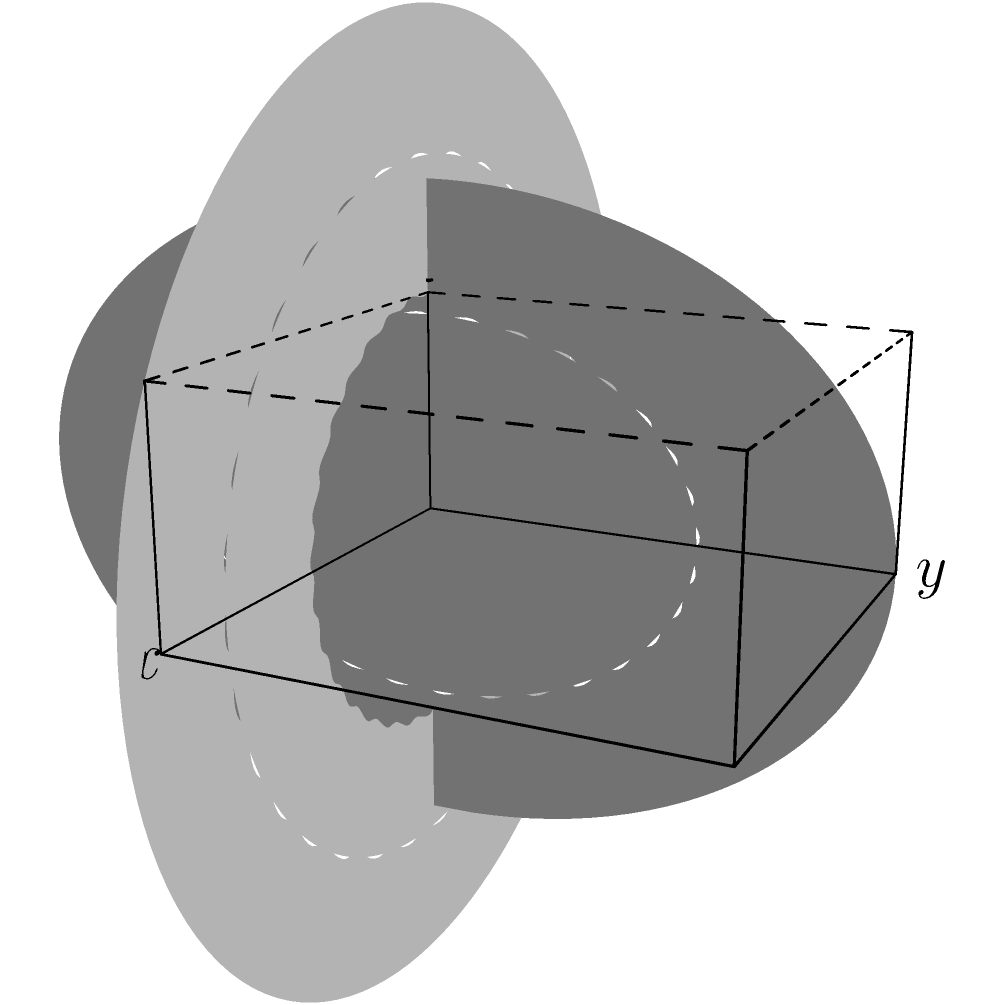As a jazz pianist, you're intrigued by the mathematical modeling of your instrument. Consider a grand piano modeled as a 3D shape with curved surfaces, as shown in the figure. The top surface is defined by the function $z = f(x) = 2 + 0.5\sin(\frac{\pi x}{4})$ for $0 \leq x \leq 4$, and the side surface is defined by $z = g(y) = 2\sin(\frac{\pi y}{3})$ for $0 \leq y \leq 3$. Calculate the volume of this piano model using triple integration. To calculate the volume of the piano model, we need to set up a triple integral. We'll integrate over x, y, and z in that order.

Step 1: Determine the limits of integration
x: 0 to 4
y: 0 to 3
z: 0 to min(f(x), g(y))

Step 2: Set up the triple integral
$$V = \int_0^4 \int_0^3 \int_0^{\min(f(x),g(y))} dz dy dx$$

Step 3: Evaluate the innermost integral
$$V = \int_0^4 \int_0^3 \min(f(x),g(y)) dy dx$$

Step 4: Substitute the functions
$$V = \int_0^4 \int_0^3 \min(2 + 0.5\sin(\frac{\pi x}{4}), 2\sin(\frac{\pi y}{3})) dy dx$$

Step 5: This integral is complex and doesn't have a straightforward analytical solution. We would typically use numerical methods to evaluate it.

Step 6: Using numerical integration (e.g., Simpson's rule or a computer algebra system), we can approximate the result.

Let's say the numerical result is approximately 21.5 cubic units.
Answer: Approximately 21.5 cubic units 